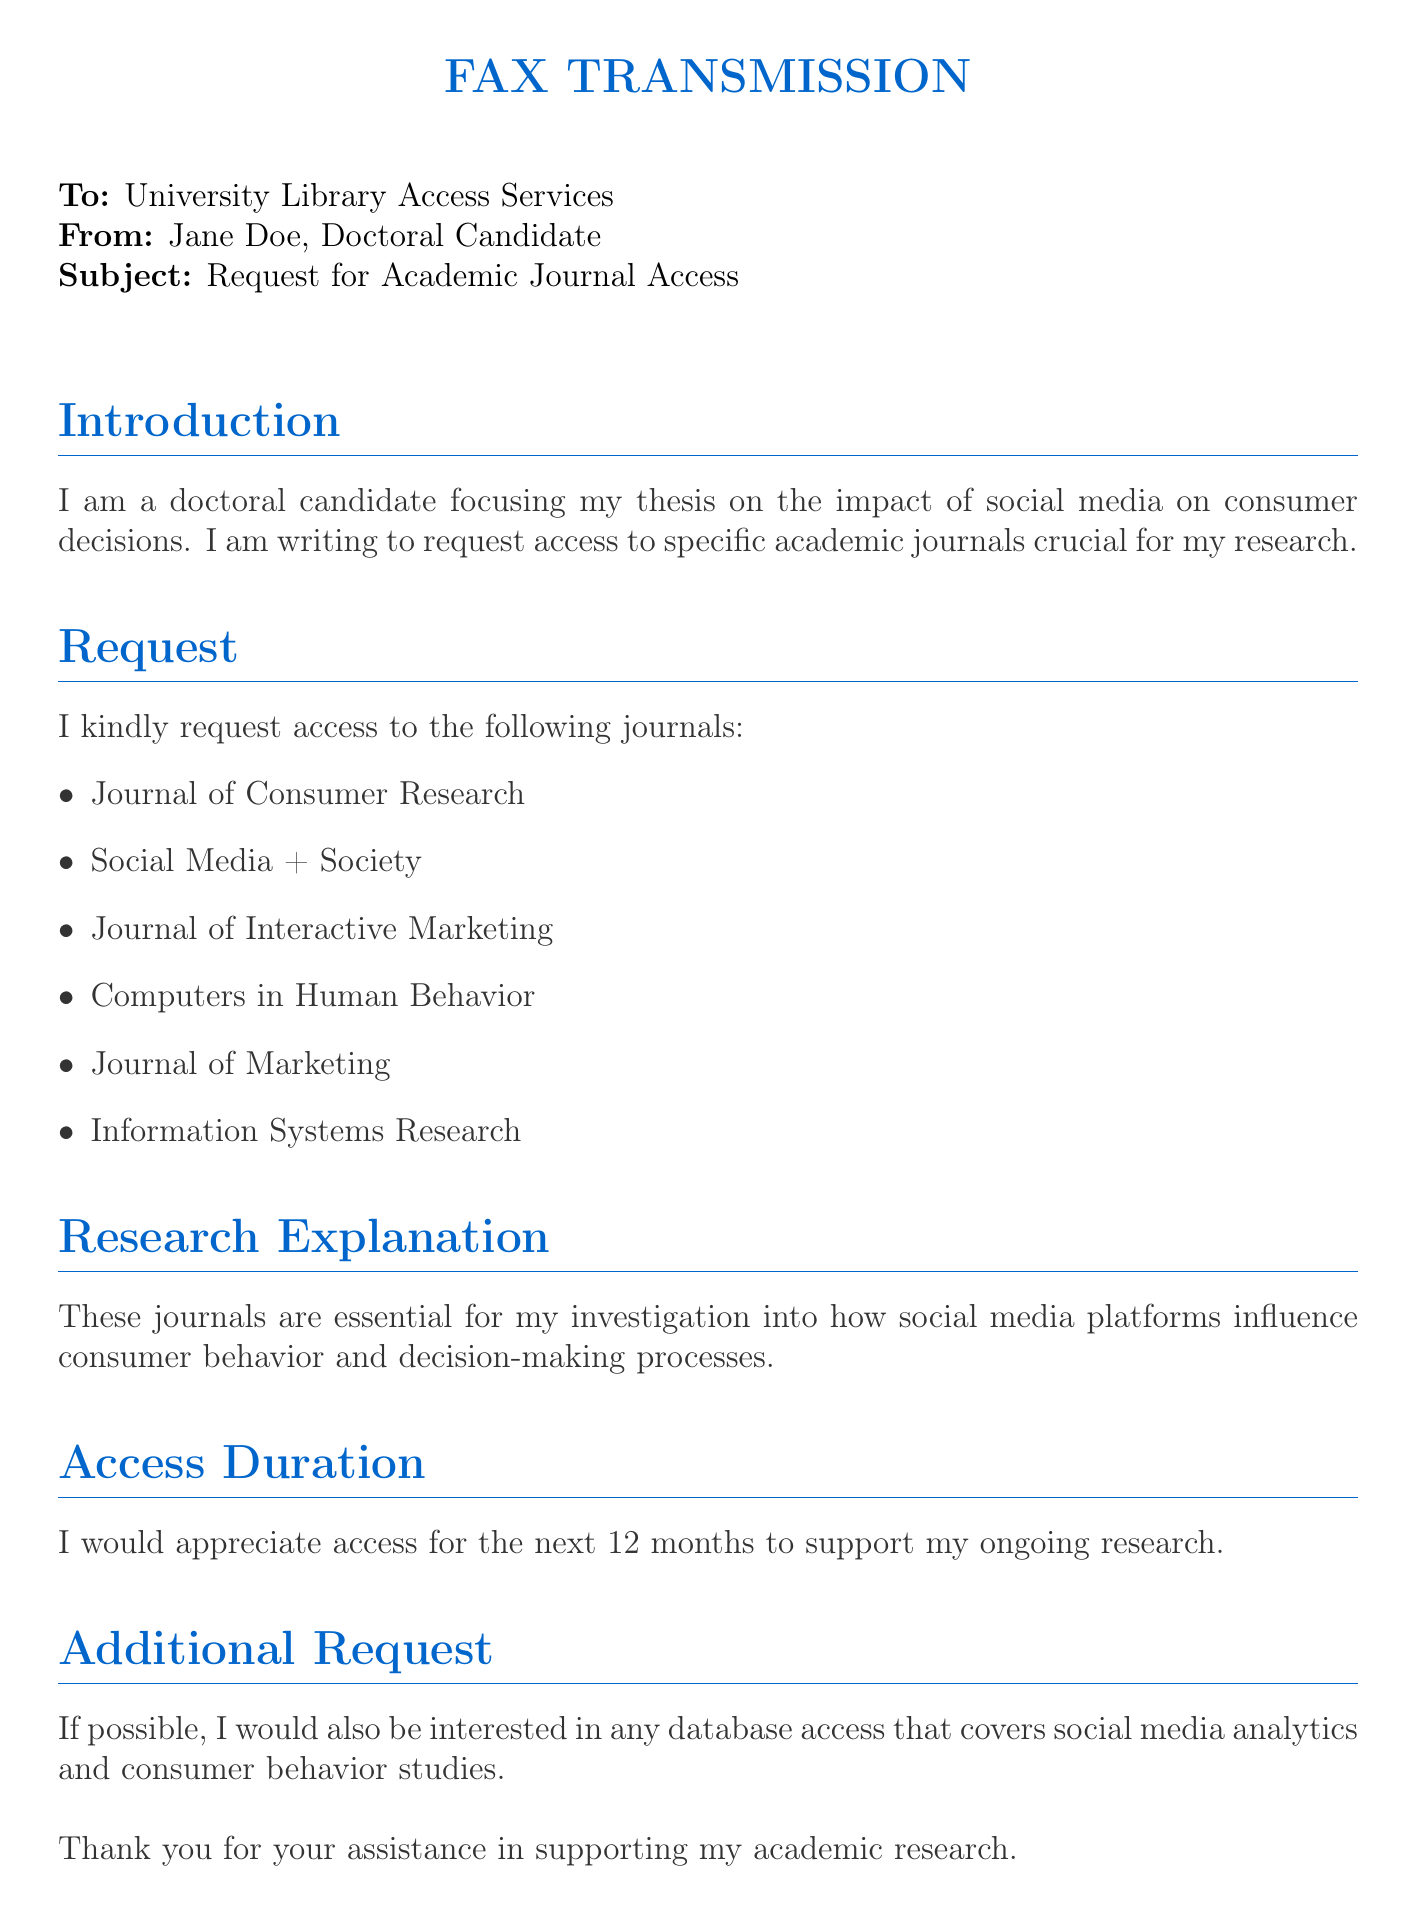What is the sender's name? The sender's name is listed at the top of the document as "Jane Doe."
Answer: Jane Doe How long is access being requested for? The duration of access is explicitly stated in the request section, which is for the next 12 months.
Answer: 12 months What is the subject of the fax? The subject of the fax is noted below the sender's information, stating it is a request for academic journal access.
Answer: Request for Academic Journal Access Which journal focuses on social media and its societal impacts? One of the journals requested in the list specifically pertains to social media, which is mentioned clearly as "Social Media + Society."
Answer: Social Media + Society What is the purpose of the research outlined in the document? The purpose of the research is detailed in the research explanation section, which describes investigating how social media platforms influence consumer behavior.
Answer: To investigate how social media influences consumer behavior Which academic area is the doctoral candidate focusing on? The introductory section specifies that the focus area is on the impact of social media on consumer decisions.
Answer: Impact of social media on consumer decisions What additional database access is mentioned? The additional request section indicates interest in database access covering social media analytics and consumer behavior studies.
Answer: Social media analytics and consumer behavior studies What is the recipient's entity mentioned in the document? The document clearly addresses the University Library Access Services as the recipient of the fax.
Answer: University Library Access Services 